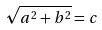<formula> <loc_0><loc_0><loc_500><loc_500>\sqrt { a ^ { 2 } + b ^ { 2 } } = c</formula> 